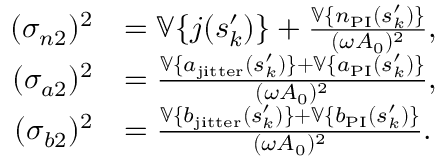<formula> <loc_0><loc_0><loc_500><loc_500>\begin{array} { r l } { ( \sigma _ { n 2 } ) ^ { 2 } } & { = \mathbb { V } \{ j ( s _ { k } ^ { \prime } ) \} + \frac { \mathbb { V } \{ n _ { P I } ( s _ { k } ^ { \prime } ) \} } { ( \omega A _ { 0 } ) ^ { 2 } } , } \\ { ( \sigma _ { a 2 } ) ^ { 2 } } & { = \frac { \mathbb { V } \{ a _ { j i t t e r } ( s _ { k } ^ { \prime } ) \} + \mathbb { V } \{ a _ { P I } ( s _ { k } ^ { \prime } ) \} } { ( \omega A _ { 0 } ) ^ { 2 } } , } \\ { ( \sigma _ { b 2 } ) ^ { 2 } } & { = \frac { \mathbb { V } \{ b _ { j i t t e r } ( s _ { k } ^ { \prime } ) \} + \mathbb { V } \{ b _ { P I } ( s _ { k } ^ { \prime } ) \} } { ( \omega A _ { 0 } ) ^ { 2 } } . } \end{array}</formula> 